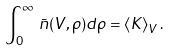<formula> <loc_0><loc_0><loc_500><loc_500>\int _ { 0 } ^ { \infty } \, \bar { n } ( V , \rho ) d \rho = \langle K \rangle _ { V } \, .</formula> 